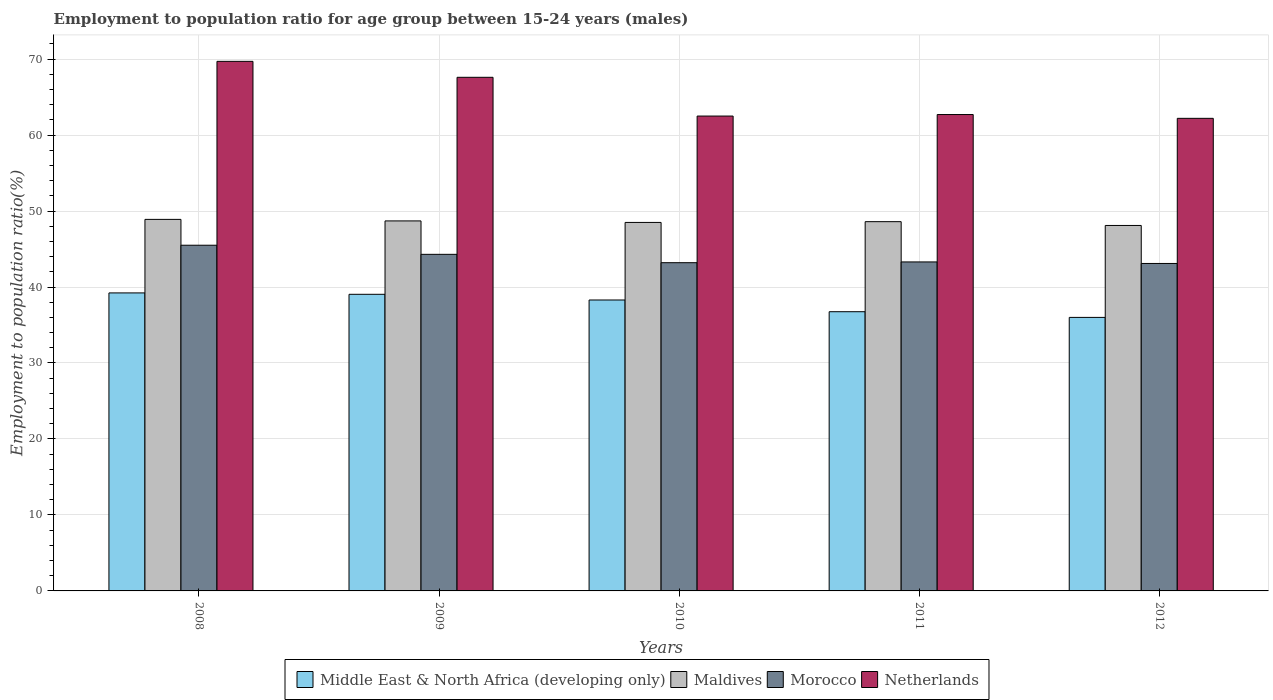Are the number of bars per tick equal to the number of legend labels?
Your answer should be very brief. Yes. Are the number of bars on each tick of the X-axis equal?
Your answer should be very brief. Yes. How many bars are there on the 3rd tick from the right?
Your response must be concise. 4. What is the employment to population ratio in Netherlands in 2009?
Provide a short and direct response. 67.6. Across all years, what is the maximum employment to population ratio in Morocco?
Your response must be concise. 45.5. Across all years, what is the minimum employment to population ratio in Maldives?
Give a very brief answer. 48.1. In which year was the employment to population ratio in Middle East & North Africa (developing only) maximum?
Your answer should be very brief. 2008. In which year was the employment to population ratio in Maldives minimum?
Ensure brevity in your answer.  2012. What is the total employment to population ratio in Netherlands in the graph?
Your answer should be compact. 324.7. What is the difference between the employment to population ratio in Middle East & North Africa (developing only) in 2008 and that in 2011?
Ensure brevity in your answer.  2.48. What is the difference between the employment to population ratio in Maldives in 2008 and the employment to population ratio in Morocco in 2012?
Provide a succinct answer. 5.8. What is the average employment to population ratio in Morocco per year?
Your answer should be very brief. 43.88. In the year 2008, what is the difference between the employment to population ratio in Middle East & North Africa (developing only) and employment to population ratio in Morocco?
Your answer should be very brief. -6.28. What is the ratio of the employment to population ratio in Maldives in 2010 to that in 2011?
Provide a short and direct response. 1. What is the difference between the highest and the second highest employment to population ratio in Maldives?
Ensure brevity in your answer.  0.2. What is the difference between the highest and the lowest employment to population ratio in Middle East & North Africa (developing only)?
Ensure brevity in your answer.  3.22. In how many years, is the employment to population ratio in Middle East & North Africa (developing only) greater than the average employment to population ratio in Middle East & North Africa (developing only) taken over all years?
Provide a succinct answer. 3. Is it the case that in every year, the sum of the employment to population ratio in Morocco and employment to population ratio in Maldives is greater than the sum of employment to population ratio in Netherlands and employment to population ratio in Middle East & North Africa (developing only)?
Keep it short and to the point. Yes. What does the 1st bar from the left in 2008 represents?
Provide a succinct answer. Middle East & North Africa (developing only). What does the 4th bar from the right in 2012 represents?
Offer a very short reply. Middle East & North Africa (developing only). How many bars are there?
Provide a succinct answer. 20. Are all the bars in the graph horizontal?
Your response must be concise. No. What is the title of the graph?
Your answer should be very brief. Employment to population ratio for age group between 15-24 years (males). What is the Employment to population ratio(%) of Middle East & North Africa (developing only) in 2008?
Offer a very short reply. 39.22. What is the Employment to population ratio(%) of Maldives in 2008?
Offer a terse response. 48.9. What is the Employment to population ratio(%) in Morocco in 2008?
Provide a succinct answer. 45.5. What is the Employment to population ratio(%) of Netherlands in 2008?
Provide a succinct answer. 69.7. What is the Employment to population ratio(%) in Middle East & North Africa (developing only) in 2009?
Provide a short and direct response. 39.04. What is the Employment to population ratio(%) of Maldives in 2009?
Your answer should be very brief. 48.7. What is the Employment to population ratio(%) in Morocco in 2009?
Offer a terse response. 44.3. What is the Employment to population ratio(%) of Netherlands in 2009?
Keep it short and to the point. 67.6. What is the Employment to population ratio(%) in Middle East & North Africa (developing only) in 2010?
Provide a succinct answer. 38.29. What is the Employment to population ratio(%) of Maldives in 2010?
Make the answer very short. 48.5. What is the Employment to population ratio(%) in Morocco in 2010?
Keep it short and to the point. 43.2. What is the Employment to population ratio(%) in Netherlands in 2010?
Provide a succinct answer. 62.5. What is the Employment to population ratio(%) in Middle East & North Africa (developing only) in 2011?
Give a very brief answer. 36.75. What is the Employment to population ratio(%) in Maldives in 2011?
Ensure brevity in your answer.  48.6. What is the Employment to population ratio(%) in Morocco in 2011?
Provide a short and direct response. 43.3. What is the Employment to population ratio(%) of Netherlands in 2011?
Keep it short and to the point. 62.7. What is the Employment to population ratio(%) of Middle East & North Africa (developing only) in 2012?
Your response must be concise. 36. What is the Employment to population ratio(%) of Maldives in 2012?
Your answer should be very brief. 48.1. What is the Employment to population ratio(%) in Morocco in 2012?
Your answer should be compact. 43.1. What is the Employment to population ratio(%) of Netherlands in 2012?
Your answer should be compact. 62.2. Across all years, what is the maximum Employment to population ratio(%) in Middle East & North Africa (developing only)?
Provide a short and direct response. 39.22. Across all years, what is the maximum Employment to population ratio(%) in Maldives?
Provide a short and direct response. 48.9. Across all years, what is the maximum Employment to population ratio(%) in Morocco?
Your answer should be very brief. 45.5. Across all years, what is the maximum Employment to population ratio(%) in Netherlands?
Provide a short and direct response. 69.7. Across all years, what is the minimum Employment to population ratio(%) in Middle East & North Africa (developing only)?
Make the answer very short. 36. Across all years, what is the minimum Employment to population ratio(%) of Maldives?
Offer a very short reply. 48.1. Across all years, what is the minimum Employment to population ratio(%) in Morocco?
Your answer should be very brief. 43.1. Across all years, what is the minimum Employment to population ratio(%) of Netherlands?
Ensure brevity in your answer.  62.2. What is the total Employment to population ratio(%) of Middle East & North Africa (developing only) in the graph?
Give a very brief answer. 189.3. What is the total Employment to population ratio(%) in Maldives in the graph?
Your response must be concise. 242.8. What is the total Employment to population ratio(%) of Morocco in the graph?
Your answer should be very brief. 219.4. What is the total Employment to population ratio(%) of Netherlands in the graph?
Provide a short and direct response. 324.7. What is the difference between the Employment to population ratio(%) of Middle East & North Africa (developing only) in 2008 and that in 2009?
Your answer should be compact. 0.18. What is the difference between the Employment to population ratio(%) in Maldives in 2008 and that in 2009?
Your answer should be very brief. 0.2. What is the difference between the Employment to population ratio(%) of Netherlands in 2008 and that in 2009?
Give a very brief answer. 2.1. What is the difference between the Employment to population ratio(%) in Middle East & North Africa (developing only) in 2008 and that in 2010?
Provide a short and direct response. 0.93. What is the difference between the Employment to population ratio(%) of Morocco in 2008 and that in 2010?
Provide a short and direct response. 2.3. What is the difference between the Employment to population ratio(%) of Middle East & North Africa (developing only) in 2008 and that in 2011?
Your response must be concise. 2.48. What is the difference between the Employment to population ratio(%) of Middle East & North Africa (developing only) in 2008 and that in 2012?
Ensure brevity in your answer.  3.22. What is the difference between the Employment to population ratio(%) of Maldives in 2008 and that in 2012?
Your response must be concise. 0.8. What is the difference between the Employment to population ratio(%) of Morocco in 2008 and that in 2012?
Offer a terse response. 2.4. What is the difference between the Employment to population ratio(%) in Middle East & North Africa (developing only) in 2009 and that in 2010?
Give a very brief answer. 0.75. What is the difference between the Employment to population ratio(%) of Middle East & North Africa (developing only) in 2009 and that in 2011?
Provide a succinct answer. 2.29. What is the difference between the Employment to population ratio(%) in Maldives in 2009 and that in 2011?
Provide a short and direct response. 0.1. What is the difference between the Employment to population ratio(%) in Morocco in 2009 and that in 2011?
Offer a terse response. 1. What is the difference between the Employment to population ratio(%) in Netherlands in 2009 and that in 2011?
Your answer should be compact. 4.9. What is the difference between the Employment to population ratio(%) in Middle East & North Africa (developing only) in 2009 and that in 2012?
Give a very brief answer. 3.04. What is the difference between the Employment to population ratio(%) in Netherlands in 2009 and that in 2012?
Your answer should be very brief. 5.4. What is the difference between the Employment to population ratio(%) of Middle East & North Africa (developing only) in 2010 and that in 2011?
Offer a very short reply. 1.54. What is the difference between the Employment to population ratio(%) in Maldives in 2010 and that in 2011?
Offer a terse response. -0.1. What is the difference between the Employment to population ratio(%) of Netherlands in 2010 and that in 2011?
Make the answer very short. -0.2. What is the difference between the Employment to population ratio(%) of Middle East & North Africa (developing only) in 2010 and that in 2012?
Give a very brief answer. 2.29. What is the difference between the Employment to population ratio(%) of Morocco in 2010 and that in 2012?
Ensure brevity in your answer.  0.1. What is the difference between the Employment to population ratio(%) of Middle East & North Africa (developing only) in 2011 and that in 2012?
Give a very brief answer. 0.75. What is the difference between the Employment to population ratio(%) in Middle East & North Africa (developing only) in 2008 and the Employment to population ratio(%) in Maldives in 2009?
Keep it short and to the point. -9.48. What is the difference between the Employment to population ratio(%) in Middle East & North Africa (developing only) in 2008 and the Employment to population ratio(%) in Morocco in 2009?
Your answer should be very brief. -5.08. What is the difference between the Employment to population ratio(%) of Middle East & North Africa (developing only) in 2008 and the Employment to population ratio(%) of Netherlands in 2009?
Offer a terse response. -28.38. What is the difference between the Employment to population ratio(%) in Maldives in 2008 and the Employment to population ratio(%) in Netherlands in 2009?
Make the answer very short. -18.7. What is the difference between the Employment to population ratio(%) of Morocco in 2008 and the Employment to population ratio(%) of Netherlands in 2009?
Keep it short and to the point. -22.1. What is the difference between the Employment to population ratio(%) of Middle East & North Africa (developing only) in 2008 and the Employment to population ratio(%) of Maldives in 2010?
Provide a succinct answer. -9.28. What is the difference between the Employment to population ratio(%) of Middle East & North Africa (developing only) in 2008 and the Employment to population ratio(%) of Morocco in 2010?
Give a very brief answer. -3.98. What is the difference between the Employment to population ratio(%) of Middle East & North Africa (developing only) in 2008 and the Employment to population ratio(%) of Netherlands in 2010?
Keep it short and to the point. -23.28. What is the difference between the Employment to population ratio(%) in Maldives in 2008 and the Employment to population ratio(%) in Morocco in 2010?
Ensure brevity in your answer.  5.7. What is the difference between the Employment to population ratio(%) in Middle East & North Africa (developing only) in 2008 and the Employment to population ratio(%) in Maldives in 2011?
Ensure brevity in your answer.  -9.38. What is the difference between the Employment to population ratio(%) of Middle East & North Africa (developing only) in 2008 and the Employment to population ratio(%) of Morocco in 2011?
Your answer should be compact. -4.08. What is the difference between the Employment to population ratio(%) in Middle East & North Africa (developing only) in 2008 and the Employment to population ratio(%) in Netherlands in 2011?
Keep it short and to the point. -23.48. What is the difference between the Employment to population ratio(%) in Maldives in 2008 and the Employment to population ratio(%) in Morocco in 2011?
Offer a terse response. 5.6. What is the difference between the Employment to population ratio(%) of Maldives in 2008 and the Employment to population ratio(%) of Netherlands in 2011?
Your answer should be very brief. -13.8. What is the difference between the Employment to population ratio(%) in Morocco in 2008 and the Employment to population ratio(%) in Netherlands in 2011?
Your answer should be compact. -17.2. What is the difference between the Employment to population ratio(%) in Middle East & North Africa (developing only) in 2008 and the Employment to population ratio(%) in Maldives in 2012?
Provide a short and direct response. -8.88. What is the difference between the Employment to population ratio(%) of Middle East & North Africa (developing only) in 2008 and the Employment to population ratio(%) of Morocco in 2012?
Your response must be concise. -3.88. What is the difference between the Employment to population ratio(%) in Middle East & North Africa (developing only) in 2008 and the Employment to population ratio(%) in Netherlands in 2012?
Make the answer very short. -22.98. What is the difference between the Employment to population ratio(%) of Maldives in 2008 and the Employment to population ratio(%) of Morocco in 2012?
Offer a terse response. 5.8. What is the difference between the Employment to population ratio(%) in Maldives in 2008 and the Employment to population ratio(%) in Netherlands in 2012?
Your answer should be compact. -13.3. What is the difference between the Employment to population ratio(%) in Morocco in 2008 and the Employment to population ratio(%) in Netherlands in 2012?
Make the answer very short. -16.7. What is the difference between the Employment to population ratio(%) in Middle East & North Africa (developing only) in 2009 and the Employment to population ratio(%) in Maldives in 2010?
Your response must be concise. -9.46. What is the difference between the Employment to population ratio(%) in Middle East & North Africa (developing only) in 2009 and the Employment to population ratio(%) in Morocco in 2010?
Your answer should be compact. -4.16. What is the difference between the Employment to population ratio(%) in Middle East & North Africa (developing only) in 2009 and the Employment to population ratio(%) in Netherlands in 2010?
Ensure brevity in your answer.  -23.46. What is the difference between the Employment to population ratio(%) of Maldives in 2009 and the Employment to population ratio(%) of Morocco in 2010?
Offer a terse response. 5.5. What is the difference between the Employment to population ratio(%) of Morocco in 2009 and the Employment to population ratio(%) of Netherlands in 2010?
Provide a short and direct response. -18.2. What is the difference between the Employment to population ratio(%) of Middle East & North Africa (developing only) in 2009 and the Employment to population ratio(%) of Maldives in 2011?
Provide a short and direct response. -9.56. What is the difference between the Employment to population ratio(%) in Middle East & North Africa (developing only) in 2009 and the Employment to population ratio(%) in Morocco in 2011?
Keep it short and to the point. -4.26. What is the difference between the Employment to population ratio(%) in Middle East & North Africa (developing only) in 2009 and the Employment to population ratio(%) in Netherlands in 2011?
Ensure brevity in your answer.  -23.66. What is the difference between the Employment to population ratio(%) of Maldives in 2009 and the Employment to population ratio(%) of Morocco in 2011?
Offer a terse response. 5.4. What is the difference between the Employment to population ratio(%) in Morocco in 2009 and the Employment to population ratio(%) in Netherlands in 2011?
Provide a short and direct response. -18.4. What is the difference between the Employment to population ratio(%) of Middle East & North Africa (developing only) in 2009 and the Employment to population ratio(%) of Maldives in 2012?
Make the answer very short. -9.06. What is the difference between the Employment to population ratio(%) of Middle East & North Africa (developing only) in 2009 and the Employment to population ratio(%) of Morocco in 2012?
Offer a very short reply. -4.06. What is the difference between the Employment to population ratio(%) in Middle East & North Africa (developing only) in 2009 and the Employment to population ratio(%) in Netherlands in 2012?
Make the answer very short. -23.16. What is the difference between the Employment to population ratio(%) in Maldives in 2009 and the Employment to population ratio(%) in Netherlands in 2012?
Offer a very short reply. -13.5. What is the difference between the Employment to population ratio(%) of Morocco in 2009 and the Employment to population ratio(%) of Netherlands in 2012?
Your answer should be compact. -17.9. What is the difference between the Employment to population ratio(%) in Middle East & North Africa (developing only) in 2010 and the Employment to population ratio(%) in Maldives in 2011?
Provide a succinct answer. -10.31. What is the difference between the Employment to population ratio(%) of Middle East & North Africa (developing only) in 2010 and the Employment to population ratio(%) of Morocco in 2011?
Provide a short and direct response. -5.01. What is the difference between the Employment to population ratio(%) in Middle East & North Africa (developing only) in 2010 and the Employment to population ratio(%) in Netherlands in 2011?
Your answer should be compact. -24.41. What is the difference between the Employment to population ratio(%) of Maldives in 2010 and the Employment to population ratio(%) of Morocco in 2011?
Keep it short and to the point. 5.2. What is the difference between the Employment to population ratio(%) in Morocco in 2010 and the Employment to population ratio(%) in Netherlands in 2011?
Keep it short and to the point. -19.5. What is the difference between the Employment to population ratio(%) in Middle East & North Africa (developing only) in 2010 and the Employment to population ratio(%) in Maldives in 2012?
Your answer should be compact. -9.81. What is the difference between the Employment to population ratio(%) of Middle East & North Africa (developing only) in 2010 and the Employment to population ratio(%) of Morocco in 2012?
Provide a short and direct response. -4.81. What is the difference between the Employment to population ratio(%) of Middle East & North Africa (developing only) in 2010 and the Employment to population ratio(%) of Netherlands in 2012?
Make the answer very short. -23.91. What is the difference between the Employment to population ratio(%) in Maldives in 2010 and the Employment to population ratio(%) in Morocco in 2012?
Ensure brevity in your answer.  5.4. What is the difference between the Employment to population ratio(%) of Maldives in 2010 and the Employment to population ratio(%) of Netherlands in 2012?
Keep it short and to the point. -13.7. What is the difference between the Employment to population ratio(%) of Morocco in 2010 and the Employment to population ratio(%) of Netherlands in 2012?
Your answer should be very brief. -19. What is the difference between the Employment to population ratio(%) in Middle East & North Africa (developing only) in 2011 and the Employment to population ratio(%) in Maldives in 2012?
Keep it short and to the point. -11.35. What is the difference between the Employment to population ratio(%) in Middle East & North Africa (developing only) in 2011 and the Employment to population ratio(%) in Morocco in 2012?
Your answer should be compact. -6.35. What is the difference between the Employment to population ratio(%) of Middle East & North Africa (developing only) in 2011 and the Employment to population ratio(%) of Netherlands in 2012?
Offer a terse response. -25.45. What is the difference between the Employment to population ratio(%) in Maldives in 2011 and the Employment to population ratio(%) in Morocco in 2012?
Ensure brevity in your answer.  5.5. What is the difference between the Employment to population ratio(%) in Maldives in 2011 and the Employment to population ratio(%) in Netherlands in 2012?
Your response must be concise. -13.6. What is the difference between the Employment to population ratio(%) of Morocco in 2011 and the Employment to population ratio(%) of Netherlands in 2012?
Your answer should be very brief. -18.9. What is the average Employment to population ratio(%) of Middle East & North Africa (developing only) per year?
Your response must be concise. 37.86. What is the average Employment to population ratio(%) in Maldives per year?
Keep it short and to the point. 48.56. What is the average Employment to population ratio(%) of Morocco per year?
Your answer should be compact. 43.88. What is the average Employment to population ratio(%) of Netherlands per year?
Your answer should be very brief. 64.94. In the year 2008, what is the difference between the Employment to population ratio(%) of Middle East & North Africa (developing only) and Employment to population ratio(%) of Maldives?
Your answer should be very brief. -9.68. In the year 2008, what is the difference between the Employment to population ratio(%) of Middle East & North Africa (developing only) and Employment to population ratio(%) of Morocco?
Your answer should be very brief. -6.28. In the year 2008, what is the difference between the Employment to population ratio(%) of Middle East & North Africa (developing only) and Employment to population ratio(%) of Netherlands?
Your answer should be very brief. -30.48. In the year 2008, what is the difference between the Employment to population ratio(%) in Maldives and Employment to population ratio(%) in Netherlands?
Your answer should be very brief. -20.8. In the year 2008, what is the difference between the Employment to population ratio(%) of Morocco and Employment to population ratio(%) of Netherlands?
Make the answer very short. -24.2. In the year 2009, what is the difference between the Employment to population ratio(%) of Middle East & North Africa (developing only) and Employment to population ratio(%) of Maldives?
Offer a very short reply. -9.66. In the year 2009, what is the difference between the Employment to population ratio(%) of Middle East & North Africa (developing only) and Employment to population ratio(%) of Morocco?
Provide a succinct answer. -5.26. In the year 2009, what is the difference between the Employment to population ratio(%) in Middle East & North Africa (developing only) and Employment to population ratio(%) in Netherlands?
Provide a short and direct response. -28.56. In the year 2009, what is the difference between the Employment to population ratio(%) of Maldives and Employment to population ratio(%) of Morocco?
Your answer should be very brief. 4.4. In the year 2009, what is the difference between the Employment to population ratio(%) of Maldives and Employment to population ratio(%) of Netherlands?
Keep it short and to the point. -18.9. In the year 2009, what is the difference between the Employment to population ratio(%) in Morocco and Employment to population ratio(%) in Netherlands?
Your answer should be very brief. -23.3. In the year 2010, what is the difference between the Employment to population ratio(%) in Middle East & North Africa (developing only) and Employment to population ratio(%) in Maldives?
Provide a succinct answer. -10.21. In the year 2010, what is the difference between the Employment to population ratio(%) of Middle East & North Africa (developing only) and Employment to population ratio(%) of Morocco?
Your answer should be very brief. -4.91. In the year 2010, what is the difference between the Employment to population ratio(%) of Middle East & North Africa (developing only) and Employment to population ratio(%) of Netherlands?
Offer a very short reply. -24.21. In the year 2010, what is the difference between the Employment to population ratio(%) in Maldives and Employment to population ratio(%) in Netherlands?
Give a very brief answer. -14. In the year 2010, what is the difference between the Employment to population ratio(%) in Morocco and Employment to population ratio(%) in Netherlands?
Provide a short and direct response. -19.3. In the year 2011, what is the difference between the Employment to population ratio(%) of Middle East & North Africa (developing only) and Employment to population ratio(%) of Maldives?
Offer a terse response. -11.85. In the year 2011, what is the difference between the Employment to population ratio(%) of Middle East & North Africa (developing only) and Employment to population ratio(%) of Morocco?
Offer a very short reply. -6.55. In the year 2011, what is the difference between the Employment to population ratio(%) of Middle East & North Africa (developing only) and Employment to population ratio(%) of Netherlands?
Offer a very short reply. -25.95. In the year 2011, what is the difference between the Employment to population ratio(%) in Maldives and Employment to population ratio(%) in Netherlands?
Your answer should be very brief. -14.1. In the year 2011, what is the difference between the Employment to population ratio(%) in Morocco and Employment to population ratio(%) in Netherlands?
Offer a very short reply. -19.4. In the year 2012, what is the difference between the Employment to population ratio(%) in Middle East & North Africa (developing only) and Employment to population ratio(%) in Maldives?
Provide a succinct answer. -12.1. In the year 2012, what is the difference between the Employment to population ratio(%) in Middle East & North Africa (developing only) and Employment to population ratio(%) in Morocco?
Offer a very short reply. -7.1. In the year 2012, what is the difference between the Employment to population ratio(%) in Middle East & North Africa (developing only) and Employment to population ratio(%) in Netherlands?
Your answer should be very brief. -26.2. In the year 2012, what is the difference between the Employment to population ratio(%) in Maldives and Employment to population ratio(%) in Netherlands?
Make the answer very short. -14.1. In the year 2012, what is the difference between the Employment to population ratio(%) in Morocco and Employment to population ratio(%) in Netherlands?
Ensure brevity in your answer.  -19.1. What is the ratio of the Employment to population ratio(%) of Maldives in 2008 to that in 2009?
Ensure brevity in your answer.  1. What is the ratio of the Employment to population ratio(%) of Morocco in 2008 to that in 2009?
Make the answer very short. 1.03. What is the ratio of the Employment to population ratio(%) in Netherlands in 2008 to that in 2009?
Your response must be concise. 1.03. What is the ratio of the Employment to population ratio(%) in Middle East & North Africa (developing only) in 2008 to that in 2010?
Offer a very short reply. 1.02. What is the ratio of the Employment to population ratio(%) of Maldives in 2008 to that in 2010?
Make the answer very short. 1.01. What is the ratio of the Employment to population ratio(%) of Morocco in 2008 to that in 2010?
Offer a terse response. 1.05. What is the ratio of the Employment to population ratio(%) in Netherlands in 2008 to that in 2010?
Provide a short and direct response. 1.12. What is the ratio of the Employment to population ratio(%) in Middle East & North Africa (developing only) in 2008 to that in 2011?
Give a very brief answer. 1.07. What is the ratio of the Employment to population ratio(%) in Morocco in 2008 to that in 2011?
Provide a succinct answer. 1.05. What is the ratio of the Employment to population ratio(%) of Netherlands in 2008 to that in 2011?
Provide a short and direct response. 1.11. What is the ratio of the Employment to population ratio(%) in Middle East & North Africa (developing only) in 2008 to that in 2012?
Keep it short and to the point. 1.09. What is the ratio of the Employment to population ratio(%) in Maldives in 2008 to that in 2012?
Ensure brevity in your answer.  1.02. What is the ratio of the Employment to population ratio(%) of Morocco in 2008 to that in 2012?
Give a very brief answer. 1.06. What is the ratio of the Employment to population ratio(%) of Netherlands in 2008 to that in 2012?
Offer a terse response. 1.12. What is the ratio of the Employment to population ratio(%) of Middle East & North Africa (developing only) in 2009 to that in 2010?
Make the answer very short. 1.02. What is the ratio of the Employment to population ratio(%) of Maldives in 2009 to that in 2010?
Provide a succinct answer. 1. What is the ratio of the Employment to population ratio(%) in Morocco in 2009 to that in 2010?
Ensure brevity in your answer.  1.03. What is the ratio of the Employment to population ratio(%) of Netherlands in 2009 to that in 2010?
Your answer should be very brief. 1.08. What is the ratio of the Employment to population ratio(%) in Middle East & North Africa (developing only) in 2009 to that in 2011?
Ensure brevity in your answer.  1.06. What is the ratio of the Employment to population ratio(%) of Maldives in 2009 to that in 2011?
Your answer should be compact. 1. What is the ratio of the Employment to population ratio(%) of Morocco in 2009 to that in 2011?
Make the answer very short. 1.02. What is the ratio of the Employment to population ratio(%) in Netherlands in 2009 to that in 2011?
Your response must be concise. 1.08. What is the ratio of the Employment to population ratio(%) in Middle East & North Africa (developing only) in 2009 to that in 2012?
Your response must be concise. 1.08. What is the ratio of the Employment to population ratio(%) of Maldives in 2009 to that in 2012?
Give a very brief answer. 1.01. What is the ratio of the Employment to population ratio(%) in Morocco in 2009 to that in 2012?
Offer a terse response. 1.03. What is the ratio of the Employment to population ratio(%) in Netherlands in 2009 to that in 2012?
Provide a succinct answer. 1.09. What is the ratio of the Employment to population ratio(%) of Middle East & North Africa (developing only) in 2010 to that in 2011?
Provide a succinct answer. 1.04. What is the ratio of the Employment to population ratio(%) of Maldives in 2010 to that in 2011?
Your answer should be compact. 1. What is the ratio of the Employment to population ratio(%) of Netherlands in 2010 to that in 2011?
Offer a terse response. 1. What is the ratio of the Employment to population ratio(%) of Middle East & North Africa (developing only) in 2010 to that in 2012?
Your response must be concise. 1.06. What is the ratio of the Employment to population ratio(%) in Maldives in 2010 to that in 2012?
Your answer should be very brief. 1.01. What is the ratio of the Employment to population ratio(%) of Morocco in 2010 to that in 2012?
Your answer should be very brief. 1. What is the ratio of the Employment to population ratio(%) of Netherlands in 2010 to that in 2012?
Your response must be concise. 1. What is the ratio of the Employment to population ratio(%) in Middle East & North Africa (developing only) in 2011 to that in 2012?
Offer a very short reply. 1.02. What is the ratio of the Employment to population ratio(%) in Maldives in 2011 to that in 2012?
Make the answer very short. 1.01. What is the ratio of the Employment to population ratio(%) of Morocco in 2011 to that in 2012?
Your answer should be very brief. 1. What is the difference between the highest and the second highest Employment to population ratio(%) of Middle East & North Africa (developing only)?
Keep it short and to the point. 0.18. What is the difference between the highest and the second highest Employment to population ratio(%) of Morocco?
Offer a terse response. 1.2. What is the difference between the highest and the second highest Employment to population ratio(%) of Netherlands?
Your answer should be very brief. 2.1. What is the difference between the highest and the lowest Employment to population ratio(%) in Middle East & North Africa (developing only)?
Ensure brevity in your answer.  3.22. What is the difference between the highest and the lowest Employment to population ratio(%) of Netherlands?
Offer a terse response. 7.5. 